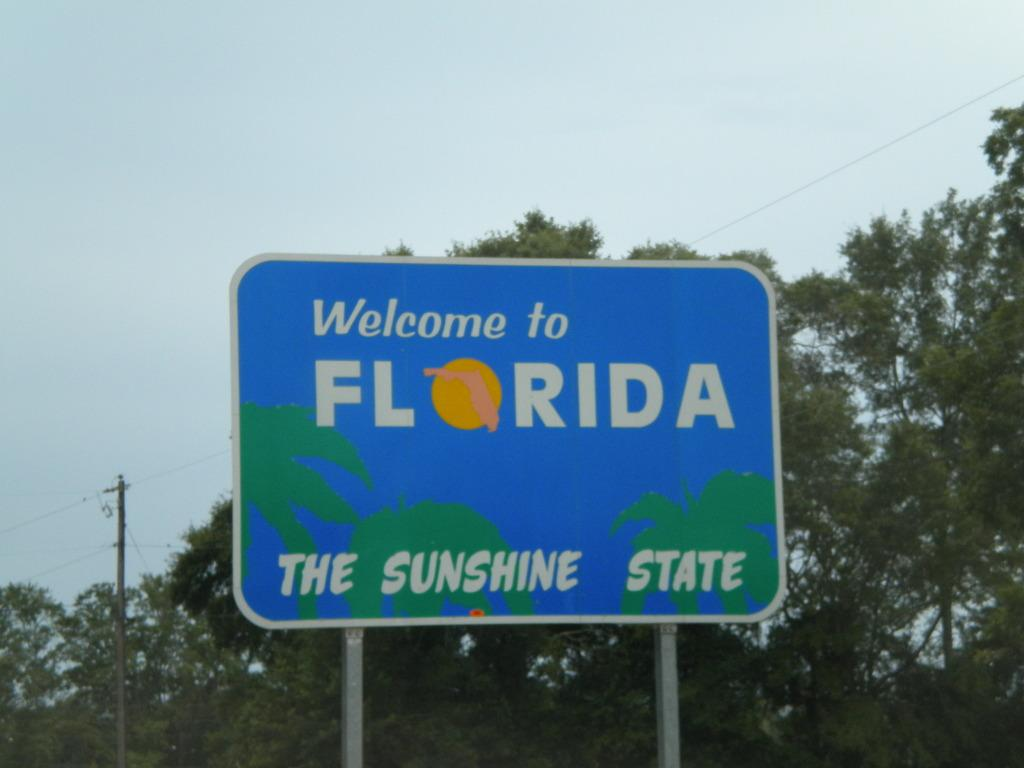<image>
Share a concise interpretation of the image provided. A blue sign that says Welcome to Florida The Sunshine State on it. 